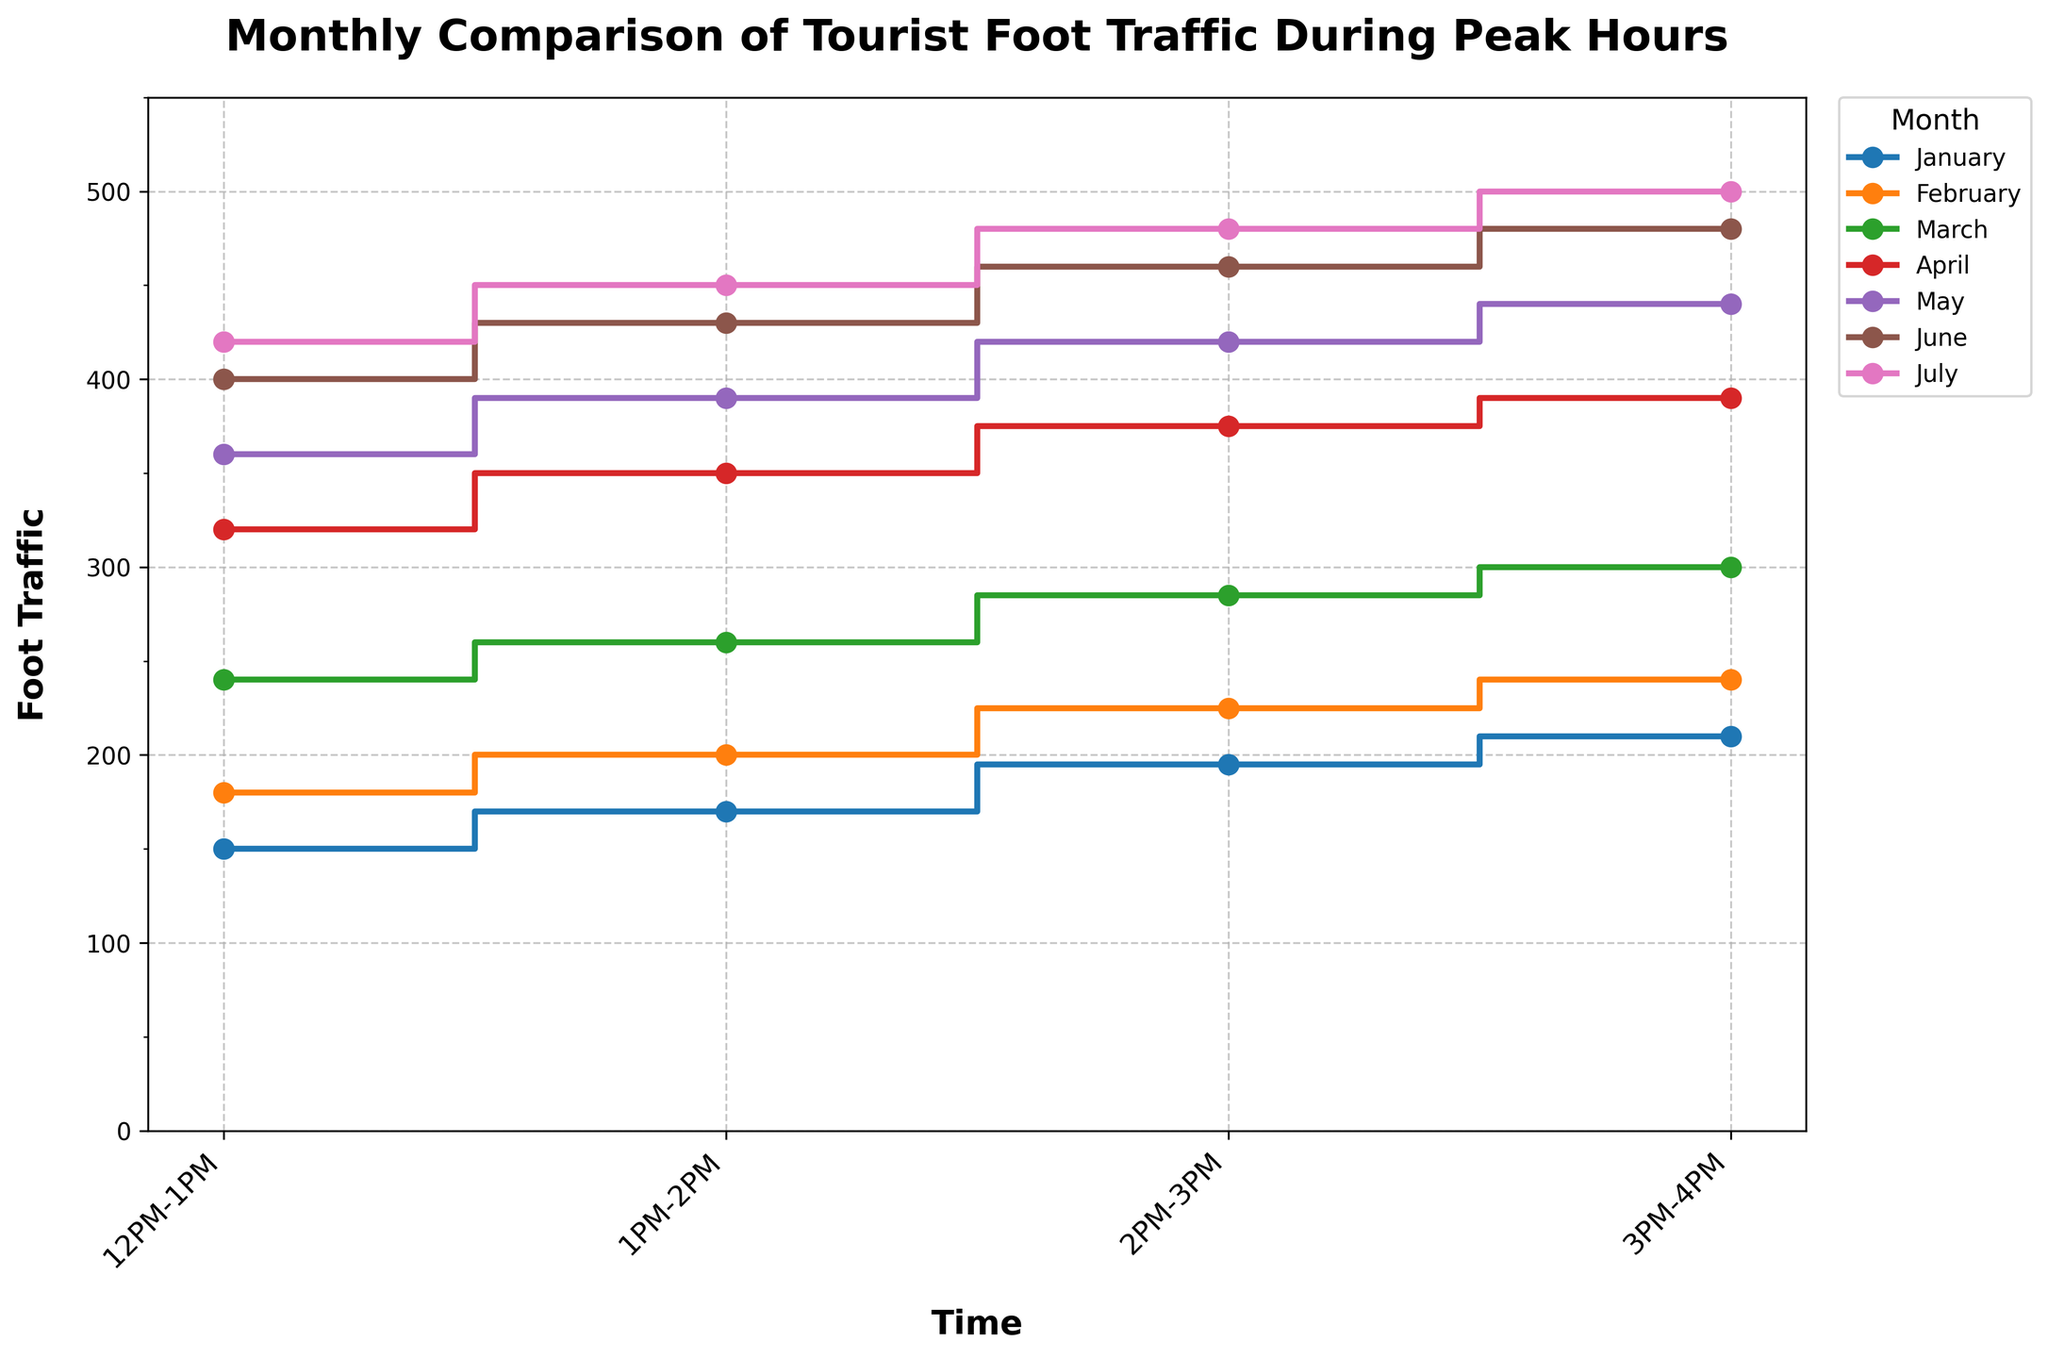What is the title of the plot? The title is displayed prominently at the top of the plot. It reads "Monthly Comparison of Tourist Foot Traffic During Peak Hours".
Answer: Monthly Comparison of Tourist Foot Traffic During Peak Hours What are the labels for the x-axis and y-axis? The x-axis label is "Time" and the y-axis label is "Foot Traffic". These labels are shown near their respective axes.
Answer: Time, Foot Traffic How does foot traffic vary from January to July around 1PM-2PM? To find the variation, look at the 1PM-2PM foot traffic values for each month from January to July. January has 170, February has 200, March has 260, April has 350, May has 390, June has 430, and July has 450.
Answer: It increases from 170 to 450 Which month has the highest tourist foot traffic during 3PM-4PM? Observe the data points along the 3PM-4PM interval for each month: January has 210, February has 240, March has 300, April has 390, May has 440, June has 480, and July has 500.
Answer: July Which month shows the most significant increase in foot traffic from 12PM-1PM to 1PM-2PM? Calculate the difference between the foot traffic for the 12PM-1PM and 1PM-2PM intervals for each month: January (170-150=20), February (200-180=20), March (260-240=20), April (350-320=30), May (390-360=30), June (430-400=30), July (450-420=30). All increases are similar, but not significant.
Answer: April, May, June, July (tie) What is the average foot traffic for May during the peak hours? Add the foot traffic data for May: 360+390+420+440 and divide by 4 (the number of time intervals). (360+390+420+440) / 4 = 1610 / 4
Answer: 402.5 In which months does the foot traffic exceed 400 at any time? Examine each interval to determine if any month exceeds 400: April (390), May (360, 390, 420, 440), June (400, 430, 460, 480), July (420, 450, 480, 500).
Answer: May, June, July How does the foot traffic in June compare to the foot traffic in January during 2PM-3PM? Compare the values directly: June has 460, while January has 195.
Answer: June's foot traffic is higher What is the trend of tourist foot traffic from 12PM-1PM to 3PM-4PM in March? Observe the values along the time intervals in March: 12PM-1PM (240), 1PM-2PM (260), 2PM-3PM (285), 3PM-4PM (300). There is a consistent increase.
Answer: It shows a rising trend What are the peak hours for the highest tourist foot traffic in April? Look at the data for April: 12PM-1PM (320), 1PM-2PM (350), 2PM-3PM (375), 3PM-4PM (390). The highest value is at 3PM-4PM.
Answer: 3PM-4PM 